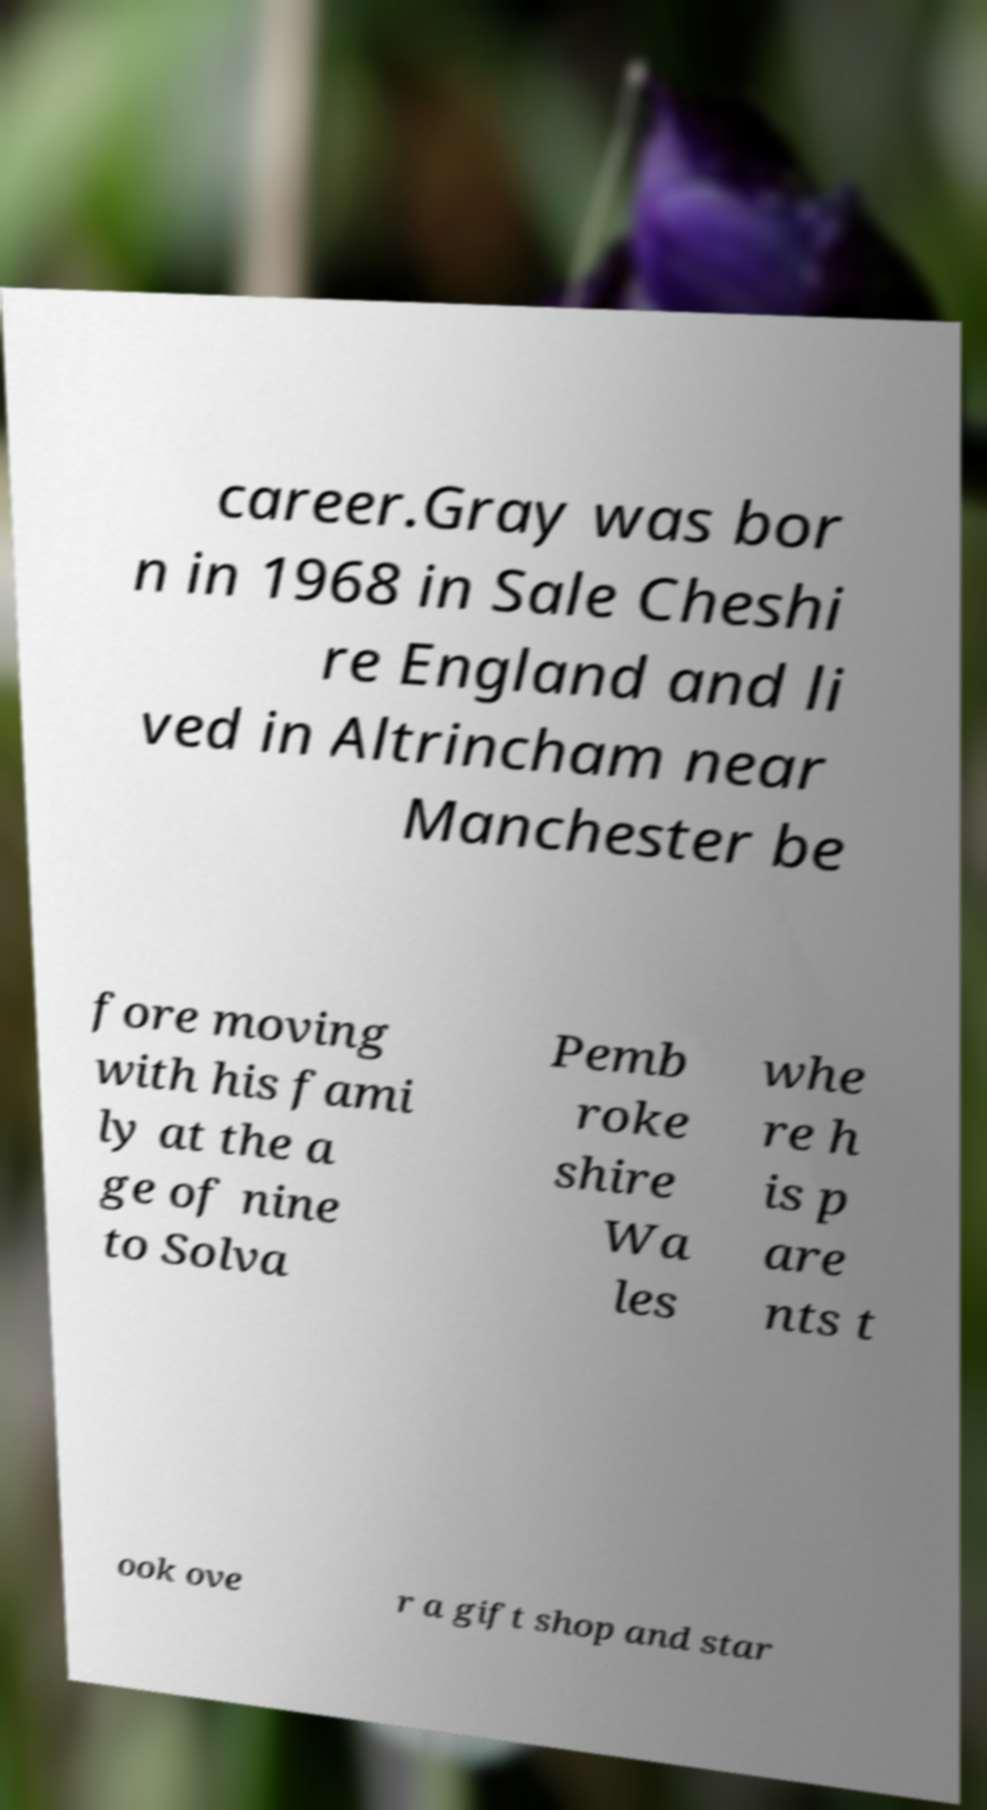I need the written content from this picture converted into text. Can you do that? career.Gray was bor n in 1968 in Sale Cheshi re England and li ved in Altrincham near Manchester be fore moving with his fami ly at the a ge of nine to Solva Pemb roke shire Wa les whe re h is p are nts t ook ove r a gift shop and star 